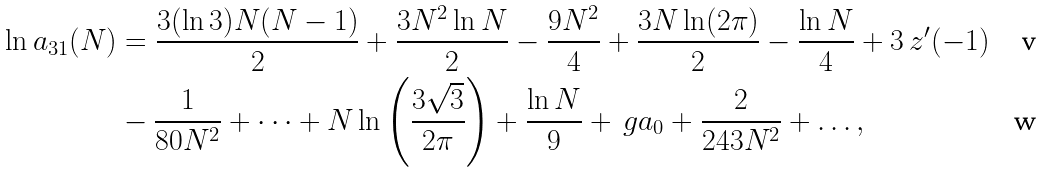<formula> <loc_0><loc_0><loc_500><loc_500>\ln a _ { 3 1 } ( N ) & = \frac { 3 ( \ln 3 ) N ( N - 1 ) } { 2 } + \frac { 3 N ^ { 2 } \ln N } { 2 } - \frac { 9 N ^ { 2 } } { 4 } + \frac { 3 N \ln ( 2 \pi ) } { 2 } - \frac { \ln N } { 4 } + 3 \ z ^ { \prime } ( - 1 ) \\ & - \frac { 1 } { 8 0 N ^ { 2 } } + \dots + N \ln \left ( \frac { 3 \sqrt { 3 } } { 2 \pi } \right ) + \frac { \ln N } { 9 } + \ g a _ { 0 } + \frac { 2 } { 2 4 3 N ^ { 2 } } + \dots ,</formula> 